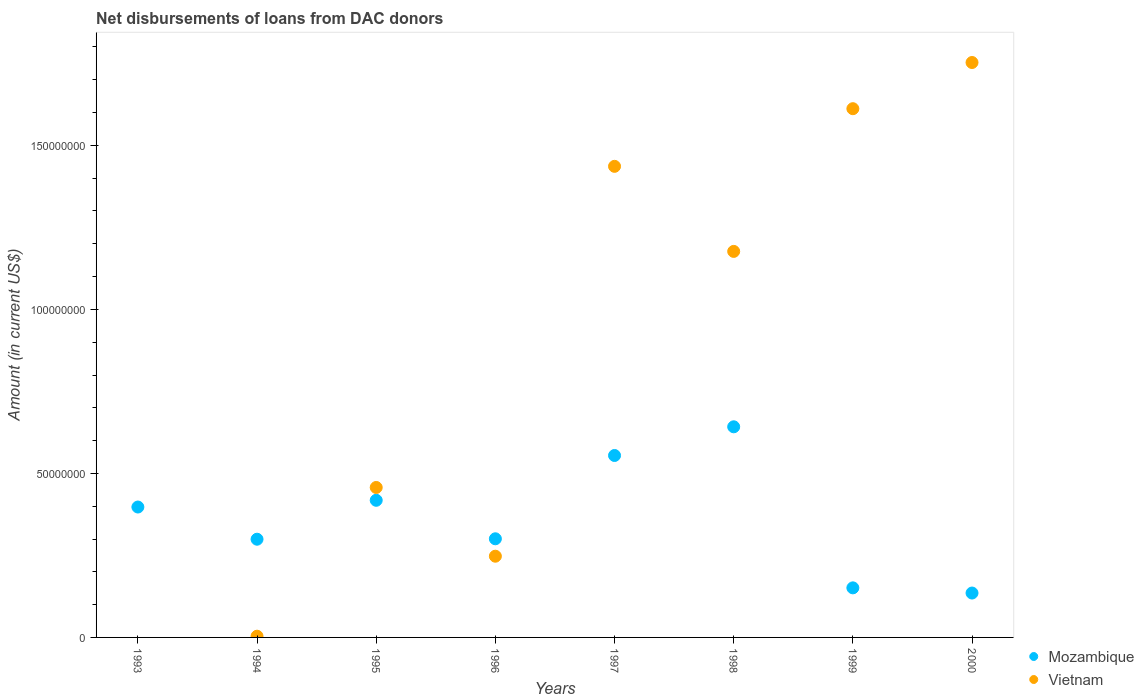What is the amount of loans disbursed in Vietnam in 2000?
Give a very brief answer. 1.75e+08. Across all years, what is the maximum amount of loans disbursed in Mozambique?
Give a very brief answer. 6.42e+07. Across all years, what is the minimum amount of loans disbursed in Vietnam?
Provide a short and direct response. 0. In which year was the amount of loans disbursed in Mozambique maximum?
Keep it short and to the point. 1998. What is the total amount of loans disbursed in Mozambique in the graph?
Offer a very short reply. 2.90e+08. What is the difference between the amount of loans disbursed in Vietnam in 1994 and that in 1998?
Provide a short and direct response. -1.17e+08. What is the difference between the amount of loans disbursed in Mozambique in 1994 and the amount of loans disbursed in Vietnam in 1995?
Keep it short and to the point. -1.58e+07. What is the average amount of loans disbursed in Mozambique per year?
Offer a very short reply. 3.62e+07. In the year 1999, what is the difference between the amount of loans disbursed in Mozambique and amount of loans disbursed in Vietnam?
Offer a terse response. -1.46e+08. What is the ratio of the amount of loans disbursed in Vietnam in 1996 to that in 1997?
Provide a succinct answer. 0.17. Is the amount of loans disbursed in Vietnam in 1999 less than that in 2000?
Your answer should be compact. Yes. Is the difference between the amount of loans disbursed in Mozambique in 1994 and 2000 greater than the difference between the amount of loans disbursed in Vietnam in 1994 and 2000?
Give a very brief answer. Yes. What is the difference between the highest and the second highest amount of loans disbursed in Vietnam?
Keep it short and to the point. 1.41e+07. What is the difference between the highest and the lowest amount of loans disbursed in Mozambique?
Provide a short and direct response. 5.07e+07. In how many years, is the amount of loans disbursed in Vietnam greater than the average amount of loans disbursed in Vietnam taken over all years?
Give a very brief answer. 4. Is the sum of the amount of loans disbursed in Mozambique in 1997 and 2000 greater than the maximum amount of loans disbursed in Vietnam across all years?
Keep it short and to the point. No. Does the amount of loans disbursed in Mozambique monotonically increase over the years?
Provide a short and direct response. No. Is the amount of loans disbursed in Vietnam strictly greater than the amount of loans disbursed in Mozambique over the years?
Make the answer very short. No. How many dotlines are there?
Keep it short and to the point. 2. What is the difference between two consecutive major ticks on the Y-axis?
Ensure brevity in your answer.  5.00e+07. Does the graph contain grids?
Ensure brevity in your answer.  No. How many legend labels are there?
Keep it short and to the point. 2. How are the legend labels stacked?
Provide a succinct answer. Vertical. What is the title of the graph?
Provide a short and direct response. Net disbursements of loans from DAC donors. What is the label or title of the X-axis?
Your response must be concise. Years. What is the Amount (in current US$) of Mozambique in 1993?
Ensure brevity in your answer.  3.98e+07. What is the Amount (in current US$) in Vietnam in 1993?
Offer a very short reply. 0. What is the Amount (in current US$) of Mozambique in 1994?
Keep it short and to the point. 2.99e+07. What is the Amount (in current US$) of Vietnam in 1994?
Give a very brief answer. 3.73e+05. What is the Amount (in current US$) in Mozambique in 1995?
Your answer should be compact. 4.18e+07. What is the Amount (in current US$) of Vietnam in 1995?
Give a very brief answer. 4.57e+07. What is the Amount (in current US$) in Mozambique in 1996?
Provide a succinct answer. 3.01e+07. What is the Amount (in current US$) in Vietnam in 1996?
Keep it short and to the point. 2.48e+07. What is the Amount (in current US$) in Mozambique in 1997?
Ensure brevity in your answer.  5.55e+07. What is the Amount (in current US$) in Vietnam in 1997?
Ensure brevity in your answer.  1.44e+08. What is the Amount (in current US$) of Mozambique in 1998?
Give a very brief answer. 6.42e+07. What is the Amount (in current US$) of Vietnam in 1998?
Your response must be concise. 1.18e+08. What is the Amount (in current US$) in Mozambique in 1999?
Ensure brevity in your answer.  1.51e+07. What is the Amount (in current US$) in Vietnam in 1999?
Give a very brief answer. 1.61e+08. What is the Amount (in current US$) in Mozambique in 2000?
Give a very brief answer. 1.35e+07. What is the Amount (in current US$) in Vietnam in 2000?
Make the answer very short. 1.75e+08. Across all years, what is the maximum Amount (in current US$) in Mozambique?
Your answer should be compact. 6.42e+07. Across all years, what is the maximum Amount (in current US$) in Vietnam?
Provide a succinct answer. 1.75e+08. Across all years, what is the minimum Amount (in current US$) of Mozambique?
Offer a terse response. 1.35e+07. Across all years, what is the minimum Amount (in current US$) of Vietnam?
Your response must be concise. 0. What is the total Amount (in current US$) of Mozambique in the graph?
Keep it short and to the point. 2.90e+08. What is the total Amount (in current US$) of Vietnam in the graph?
Keep it short and to the point. 6.69e+08. What is the difference between the Amount (in current US$) in Mozambique in 1993 and that in 1994?
Offer a very short reply. 9.81e+06. What is the difference between the Amount (in current US$) of Mozambique in 1993 and that in 1995?
Offer a very short reply. -2.05e+06. What is the difference between the Amount (in current US$) of Mozambique in 1993 and that in 1996?
Give a very brief answer. 9.68e+06. What is the difference between the Amount (in current US$) of Mozambique in 1993 and that in 1997?
Give a very brief answer. -1.57e+07. What is the difference between the Amount (in current US$) in Mozambique in 1993 and that in 1998?
Give a very brief answer. -2.45e+07. What is the difference between the Amount (in current US$) in Mozambique in 1993 and that in 1999?
Your answer should be very brief. 2.46e+07. What is the difference between the Amount (in current US$) of Mozambique in 1993 and that in 2000?
Provide a short and direct response. 2.62e+07. What is the difference between the Amount (in current US$) of Mozambique in 1994 and that in 1995?
Give a very brief answer. -1.19e+07. What is the difference between the Amount (in current US$) of Vietnam in 1994 and that in 1995?
Provide a succinct answer. -4.53e+07. What is the difference between the Amount (in current US$) in Mozambique in 1994 and that in 1996?
Provide a succinct answer. -1.31e+05. What is the difference between the Amount (in current US$) of Vietnam in 1994 and that in 1996?
Ensure brevity in your answer.  -2.44e+07. What is the difference between the Amount (in current US$) in Mozambique in 1994 and that in 1997?
Make the answer very short. -2.55e+07. What is the difference between the Amount (in current US$) in Vietnam in 1994 and that in 1997?
Keep it short and to the point. -1.43e+08. What is the difference between the Amount (in current US$) in Mozambique in 1994 and that in 1998?
Provide a succinct answer. -3.43e+07. What is the difference between the Amount (in current US$) of Vietnam in 1994 and that in 1998?
Ensure brevity in your answer.  -1.17e+08. What is the difference between the Amount (in current US$) in Mozambique in 1994 and that in 1999?
Keep it short and to the point. 1.48e+07. What is the difference between the Amount (in current US$) in Vietnam in 1994 and that in 1999?
Keep it short and to the point. -1.61e+08. What is the difference between the Amount (in current US$) of Mozambique in 1994 and that in 2000?
Your response must be concise. 1.64e+07. What is the difference between the Amount (in current US$) in Vietnam in 1994 and that in 2000?
Ensure brevity in your answer.  -1.75e+08. What is the difference between the Amount (in current US$) in Mozambique in 1995 and that in 1996?
Provide a succinct answer. 1.17e+07. What is the difference between the Amount (in current US$) of Vietnam in 1995 and that in 1996?
Offer a terse response. 2.10e+07. What is the difference between the Amount (in current US$) in Mozambique in 1995 and that in 1997?
Make the answer very short. -1.37e+07. What is the difference between the Amount (in current US$) in Vietnam in 1995 and that in 1997?
Your answer should be very brief. -9.79e+07. What is the difference between the Amount (in current US$) of Mozambique in 1995 and that in 1998?
Give a very brief answer. -2.24e+07. What is the difference between the Amount (in current US$) in Vietnam in 1995 and that in 1998?
Ensure brevity in your answer.  -7.20e+07. What is the difference between the Amount (in current US$) of Mozambique in 1995 and that in 1999?
Keep it short and to the point. 2.67e+07. What is the difference between the Amount (in current US$) of Vietnam in 1995 and that in 1999?
Give a very brief answer. -1.15e+08. What is the difference between the Amount (in current US$) of Mozambique in 1995 and that in 2000?
Your answer should be very brief. 2.83e+07. What is the difference between the Amount (in current US$) of Vietnam in 1995 and that in 2000?
Your answer should be compact. -1.30e+08. What is the difference between the Amount (in current US$) in Mozambique in 1996 and that in 1997?
Ensure brevity in your answer.  -2.54e+07. What is the difference between the Amount (in current US$) of Vietnam in 1996 and that in 1997?
Your answer should be very brief. -1.19e+08. What is the difference between the Amount (in current US$) of Mozambique in 1996 and that in 1998?
Provide a short and direct response. -3.41e+07. What is the difference between the Amount (in current US$) in Vietnam in 1996 and that in 1998?
Keep it short and to the point. -9.29e+07. What is the difference between the Amount (in current US$) of Mozambique in 1996 and that in 1999?
Your response must be concise. 1.50e+07. What is the difference between the Amount (in current US$) in Vietnam in 1996 and that in 1999?
Give a very brief answer. -1.36e+08. What is the difference between the Amount (in current US$) in Mozambique in 1996 and that in 2000?
Your response must be concise. 1.65e+07. What is the difference between the Amount (in current US$) of Vietnam in 1996 and that in 2000?
Provide a short and direct response. -1.51e+08. What is the difference between the Amount (in current US$) of Mozambique in 1997 and that in 1998?
Offer a very short reply. -8.75e+06. What is the difference between the Amount (in current US$) of Vietnam in 1997 and that in 1998?
Offer a very short reply. 2.59e+07. What is the difference between the Amount (in current US$) of Mozambique in 1997 and that in 1999?
Give a very brief answer. 4.04e+07. What is the difference between the Amount (in current US$) of Vietnam in 1997 and that in 1999?
Offer a terse response. -1.76e+07. What is the difference between the Amount (in current US$) in Mozambique in 1997 and that in 2000?
Give a very brief answer. 4.19e+07. What is the difference between the Amount (in current US$) of Vietnam in 1997 and that in 2000?
Your answer should be compact. -3.17e+07. What is the difference between the Amount (in current US$) of Mozambique in 1998 and that in 1999?
Your answer should be compact. 4.91e+07. What is the difference between the Amount (in current US$) in Vietnam in 1998 and that in 1999?
Your answer should be very brief. -4.35e+07. What is the difference between the Amount (in current US$) in Mozambique in 1998 and that in 2000?
Your response must be concise. 5.07e+07. What is the difference between the Amount (in current US$) in Vietnam in 1998 and that in 2000?
Provide a succinct answer. -5.76e+07. What is the difference between the Amount (in current US$) of Mozambique in 1999 and that in 2000?
Provide a succinct answer. 1.58e+06. What is the difference between the Amount (in current US$) in Vietnam in 1999 and that in 2000?
Your answer should be compact. -1.41e+07. What is the difference between the Amount (in current US$) in Mozambique in 1993 and the Amount (in current US$) in Vietnam in 1994?
Make the answer very short. 3.94e+07. What is the difference between the Amount (in current US$) of Mozambique in 1993 and the Amount (in current US$) of Vietnam in 1995?
Provide a succinct answer. -5.96e+06. What is the difference between the Amount (in current US$) of Mozambique in 1993 and the Amount (in current US$) of Vietnam in 1996?
Provide a succinct answer. 1.50e+07. What is the difference between the Amount (in current US$) in Mozambique in 1993 and the Amount (in current US$) in Vietnam in 1997?
Keep it short and to the point. -1.04e+08. What is the difference between the Amount (in current US$) in Mozambique in 1993 and the Amount (in current US$) in Vietnam in 1998?
Keep it short and to the point. -7.79e+07. What is the difference between the Amount (in current US$) in Mozambique in 1993 and the Amount (in current US$) in Vietnam in 1999?
Give a very brief answer. -1.21e+08. What is the difference between the Amount (in current US$) in Mozambique in 1993 and the Amount (in current US$) in Vietnam in 2000?
Make the answer very short. -1.36e+08. What is the difference between the Amount (in current US$) in Mozambique in 1994 and the Amount (in current US$) in Vietnam in 1995?
Ensure brevity in your answer.  -1.58e+07. What is the difference between the Amount (in current US$) in Mozambique in 1994 and the Amount (in current US$) in Vietnam in 1996?
Your answer should be compact. 5.18e+06. What is the difference between the Amount (in current US$) of Mozambique in 1994 and the Amount (in current US$) of Vietnam in 1997?
Offer a terse response. -1.14e+08. What is the difference between the Amount (in current US$) in Mozambique in 1994 and the Amount (in current US$) in Vietnam in 1998?
Offer a very short reply. -8.77e+07. What is the difference between the Amount (in current US$) in Mozambique in 1994 and the Amount (in current US$) in Vietnam in 1999?
Provide a succinct answer. -1.31e+08. What is the difference between the Amount (in current US$) in Mozambique in 1994 and the Amount (in current US$) in Vietnam in 2000?
Offer a terse response. -1.45e+08. What is the difference between the Amount (in current US$) in Mozambique in 1995 and the Amount (in current US$) in Vietnam in 1996?
Your answer should be very brief. 1.70e+07. What is the difference between the Amount (in current US$) in Mozambique in 1995 and the Amount (in current US$) in Vietnam in 1997?
Offer a terse response. -1.02e+08. What is the difference between the Amount (in current US$) in Mozambique in 1995 and the Amount (in current US$) in Vietnam in 1998?
Provide a short and direct response. -7.59e+07. What is the difference between the Amount (in current US$) of Mozambique in 1995 and the Amount (in current US$) of Vietnam in 1999?
Keep it short and to the point. -1.19e+08. What is the difference between the Amount (in current US$) in Mozambique in 1995 and the Amount (in current US$) in Vietnam in 2000?
Your answer should be very brief. -1.33e+08. What is the difference between the Amount (in current US$) in Mozambique in 1996 and the Amount (in current US$) in Vietnam in 1997?
Your response must be concise. -1.14e+08. What is the difference between the Amount (in current US$) in Mozambique in 1996 and the Amount (in current US$) in Vietnam in 1998?
Provide a short and direct response. -8.76e+07. What is the difference between the Amount (in current US$) in Mozambique in 1996 and the Amount (in current US$) in Vietnam in 1999?
Make the answer very short. -1.31e+08. What is the difference between the Amount (in current US$) in Mozambique in 1996 and the Amount (in current US$) in Vietnam in 2000?
Offer a very short reply. -1.45e+08. What is the difference between the Amount (in current US$) in Mozambique in 1997 and the Amount (in current US$) in Vietnam in 1998?
Provide a succinct answer. -6.22e+07. What is the difference between the Amount (in current US$) of Mozambique in 1997 and the Amount (in current US$) of Vietnam in 1999?
Keep it short and to the point. -1.06e+08. What is the difference between the Amount (in current US$) of Mozambique in 1997 and the Amount (in current US$) of Vietnam in 2000?
Offer a very short reply. -1.20e+08. What is the difference between the Amount (in current US$) of Mozambique in 1998 and the Amount (in current US$) of Vietnam in 1999?
Give a very brief answer. -9.70e+07. What is the difference between the Amount (in current US$) of Mozambique in 1998 and the Amount (in current US$) of Vietnam in 2000?
Ensure brevity in your answer.  -1.11e+08. What is the difference between the Amount (in current US$) in Mozambique in 1999 and the Amount (in current US$) in Vietnam in 2000?
Your answer should be very brief. -1.60e+08. What is the average Amount (in current US$) in Mozambique per year?
Keep it short and to the point. 3.62e+07. What is the average Amount (in current US$) in Vietnam per year?
Your response must be concise. 8.36e+07. In the year 1994, what is the difference between the Amount (in current US$) in Mozambique and Amount (in current US$) in Vietnam?
Make the answer very short. 2.96e+07. In the year 1995, what is the difference between the Amount (in current US$) in Mozambique and Amount (in current US$) in Vietnam?
Offer a terse response. -3.91e+06. In the year 1996, what is the difference between the Amount (in current US$) in Mozambique and Amount (in current US$) in Vietnam?
Your response must be concise. 5.31e+06. In the year 1997, what is the difference between the Amount (in current US$) in Mozambique and Amount (in current US$) in Vietnam?
Offer a very short reply. -8.82e+07. In the year 1998, what is the difference between the Amount (in current US$) in Mozambique and Amount (in current US$) in Vietnam?
Make the answer very short. -5.35e+07. In the year 1999, what is the difference between the Amount (in current US$) in Mozambique and Amount (in current US$) in Vietnam?
Provide a short and direct response. -1.46e+08. In the year 2000, what is the difference between the Amount (in current US$) in Mozambique and Amount (in current US$) in Vietnam?
Offer a terse response. -1.62e+08. What is the ratio of the Amount (in current US$) in Mozambique in 1993 to that in 1994?
Offer a very short reply. 1.33. What is the ratio of the Amount (in current US$) in Mozambique in 1993 to that in 1995?
Your answer should be compact. 0.95. What is the ratio of the Amount (in current US$) of Mozambique in 1993 to that in 1996?
Ensure brevity in your answer.  1.32. What is the ratio of the Amount (in current US$) of Mozambique in 1993 to that in 1997?
Offer a very short reply. 0.72. What is the ratio of the Amount (in current US$) in Mozambique in 1993 to that in 1998?
Make the answer very short. 0.62. What is the ratio of the Amount (in current US$) of Mozambique in 1993 to that in 1999?
Offer a terse response. 2.63. What is the ratio of the Amount (in current US$) of Mozambique in 1993 to that in 2000?
Your answer should be compact. 2.94. What is the ratio of the Amount (in current US$) in Mozambique in 1994 to that in 1995?
Provide a succinct answer. 0.72. What is the ratio of the Amount (in current US$) in Vietnam in 1994 to that in 1995?
Offer a very short reply. 0.01. What is the ratio of the Amount (in current US$) of Mozambique in 1994 to that in 1996?
Keep it short and to the point. 1. What is the ratio of the Amount (in current US$) of Vietnam in 1994 to that in 1996?
Provide a succinct answer. 0.02. What is the ratio of the Amount (in current US$) in Mozambique in 1994 to that in 1997?
Offer a terse response. 0.54. What is the ratio of the Amount (in current US$) of Vietnam in 1994 to that in 1997?
Offer a terse response. 0. What is the ratio of the Amount (in current US$) in Mozambique in 1994 to that in 1998?
Offer a very short reply. 0.47. What is the ratio of the Amount (in current US$) of Vietnam in 1994 to that in 1998?
Ensure brevity in your answer.  0. What is the ratio of the Amount (in current US$) in Mozambique in 1994 to that in 1999?
Give a very brief answer. 1.98. What is the ratio of the Amount (in current US$) in Vietnam in 1994 to that in 1999?
Offer a very short reply. 0. What is the ratio of the Amount (in current US$) of Mozambique in 1994 to that in 2000?
Offer a terse response. 2.21. What is the ratio of the Amount (in current US$) of Vietnam in 1994 to that in 2000?
Offer a terse response. 0. What is the ratio of the Amount (in current US$) in Mozambique in 1995 to that in 1996?
Offer a very short reply. 1.39. What is the ratio of the Amount (in current US$) in Vietnam in 1995 to that in 1996?
Provide a short and direct response. 1.85. What is the ratio of the Amount (in current US$) in Mozambique in 1995 to that in 1997?
Make the answer very short. 0.75. What is the ratio of the Amount (in current US$) in Vietnam in 1995 to that in 1997?
Provide a short and direct response. 0.32. What is the ratio of the Amount (in current US$) of Mozambique in 1995 to that in 1998?
Make the answer very short. 0.65. What is the ratio of the Amount (in current US$) of Vietnam in 1995 to that in 1998?
Ensure brevity in your answer.  0.39. What is the ratio of the Amount (in current US$) in Mozambique in 1995 to that in 1999?
Offer a terse response. 2.77. What is the ratio of the Amount (in current US$) of Vietnam in 1995 to that in 1999?
Give a very brief answer. 0.28. What is the ratio of the Amount (in current US$) of Mozambique in 1995 to that in 2000?
Ensure brevity in your answer.  3.09. What is the ratio of the Amount (in current US$) of Vietnam in 1995 to that in 2000?
Your response must be concise. 0.26. What is the ratio of the Amount (in current US$) of Mozambique in 1996 to that in 1997?
Ensure brevity in your answer.  0.54. What is the ratio of the Amount (in current US$) of Vietnam in 1996 to that in 1997?
Provide a short and direct response. 0.17. What is the ratio of the Amount (in current US$) of Mozambique in 1996 to that in 1998?
Your answer should be compact. 0.47. What is the ratio of the Amount (in current US$) of Vietnam in 1996 to that in 1998?
Give a very brief answer. 0.21. What is the ratio of the Amount (in current US$) of Mozambique in 1996 to that in 1999?
Make the answer very short. 1.99. What is the ratio of the Amount (in current US$) of Vietnam in 1996 to that in 1999?
Offer a very short reply. 0.15. What is the ratio of the Amount (in current US$) in Mozambique in 1996 to that in 2000?
Your response must be concise. 2.22. What is the ratio of the Amount (in current US$) of Vietnam in 1996 to that in 2000?
Provide a short and direct response. 0.14. What is the ratio of the Amount (in current US$) of Mozambique in 1997 to that in 1998?
Offer a terse response. 0.86. What is the ratio of the Amount (in current US$) in Vietnam in 1997 to that in 1998?
Provide a short and direct response. 1.22. What is the ratio of the Amount (in current US$) in Mozambique in 1997 to that in 1999?
Keep it short and to the point. 3.67. What is the ratio of the Amount (in current US$) of Vietnam in 1997 to that in 1999?
Offer a terse response. 0.89. What is the ratio of the Amount (in current US$) of Mozambique in 1997 to that in 2000?
Offer a very short reply. 4.1. What is the ratio of the Amount (in current US$) of Vietnam in 1997 to that in 2000?
Your answer should be compact. 0.82. What is the ratio of the Amount (in current US$) in Mozambique in 1998 to that in 1999?
Offer a terse response. 4.25. What is the ratio of the Amount (in current US$) in Vietnam in 1998 to that in 1999?
Keep it short and to the point. 0.73. What is the ratio of the Amount (in current US$) in Mozambique in 1998 to that in 2000?
Provide a succinct answer. 4.75. What is the ratio of the Amount (in current US$) of Vietnam in 1998 to that in 2000?
Make the answer very short. 0.67. What is the ratio of the Amount (in current US$) in Mozambique in 1999 to that in 2000?
Offer a terse response. 1.12. What is the ratio of the Amount (in current US$) in Vietnam in 1999 to that in 2000?
Ensure brevity in your answer.  0.92. What is the difference between the highest and the second highest Amount (in current US$) of Mozambique?
Offer a very short reply. 8.75e+06. What is the difference between the highest and the second highest Amount (in current US$) of Vietnam?
Your response must be concise. 1.41e+07. What is the difference between the highest and the lowest Amount (in current US$) of Mozambique?
Make the answer very short. 5.07e+07. What is the difference between the highest and the lowest Amount (in current US$) of Vietnam?
Your response must be concise. 1.75e+08. 